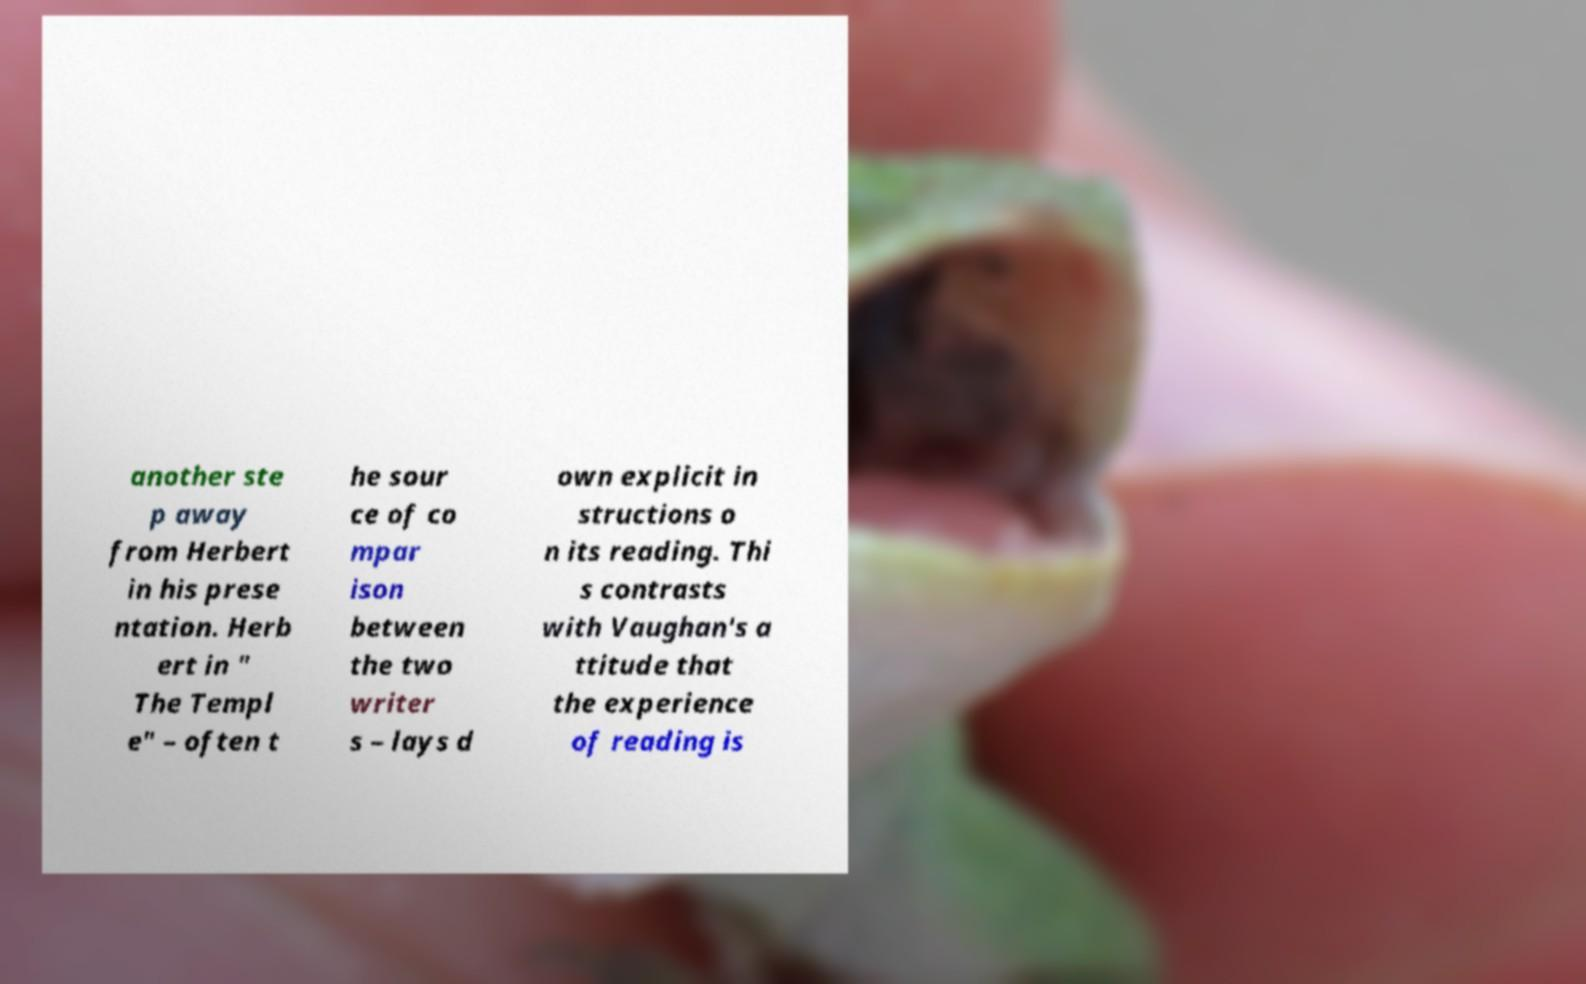Could you assist in decoding the text presented in this image and type it out clearly? another ste p away from Herbert in his prese ntation. Herb ert in " The Templ e" – often t he sour ce of co mpar ison between the two writer s – lays d own explicit in structions o n its reading. Thi s contrasts with Vaughan's a ttitude that the experience of reading is 